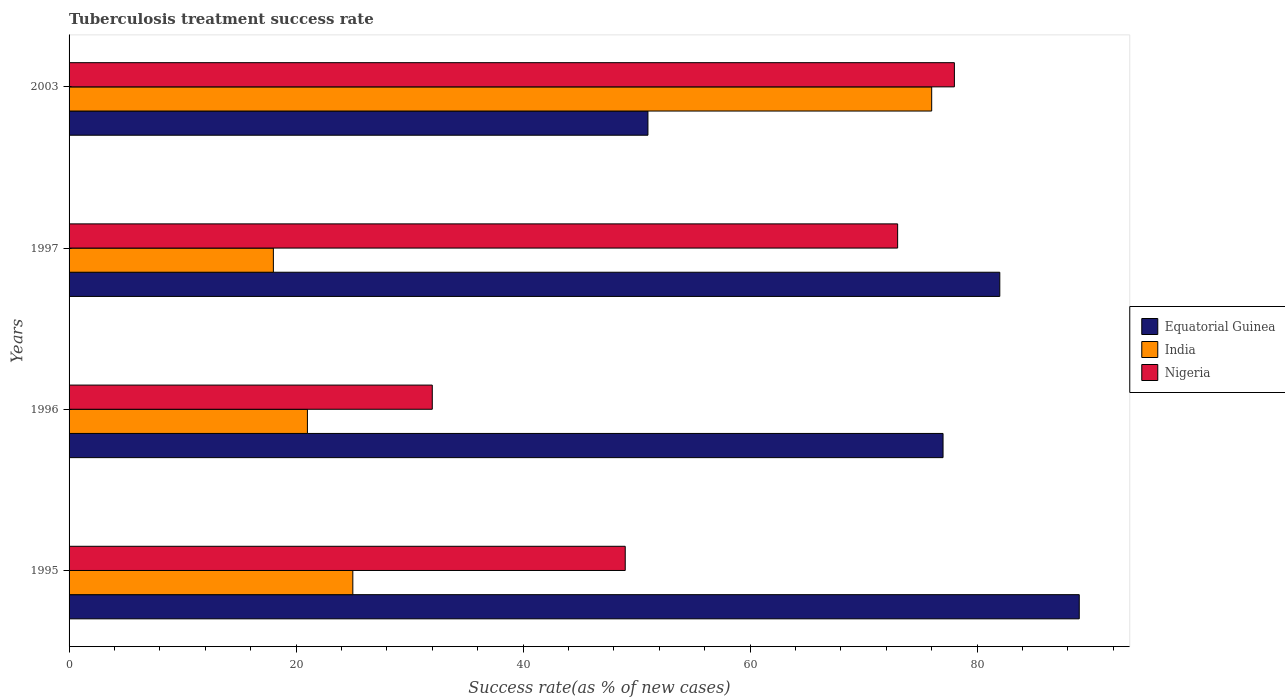How many different coloured bars are there?
Offer a very short reply. 3. What is the label of the 2nd group of bars from the top?
Offer a very short reply. 1997. In how many cases, is the number of bars for a given year not equal to the number of legend labels?
Provide a succinct answer. 0. What is the tuberculosis treatment success rate in Nigeria in 1995?
Keep it short and to the point. 49. Across all years, what is the maximum tuberculosis treatment success rate in India?
Provide a short and direct response. 76. Across all years, what is the minimum tuberculosis treatment success rate in Nigeria?
Keep it short and to the point. 32. In which year was the tuberculosis treatment success rate in Equatorial Guinea minimum?
Provide a short and direct response. 2003. What is the total tuberculosis treatment success rate in Equatorial Guinea in the graph?
Offer a very short reply. 299. What is the difference between the tuberculosis treatment success rate in Nigeria in 1996 and that in 2003?
Your answer should be very brief. -46. What is the difference between the tuberculosis treatment success rate in Nigeria in 1996 and the tuberculosis treatment success rate in India in 2003?
Your response must be concise. -44. What is the average tuberculosis treatment success rate in Nigeria per year?
Make the answer very short. 58. In how many years, is the tuberculosis treatment success rate in Nigeria greater than 48 %?
Keep it short and to the point. 3. What is the ratio of the tuberculosis treatment success rate in Nigeria in 1996 to that in 1997?
Provide a succinct answer. 0.44. Is the difference between the tuberculosis treatment success rate in Nigeria in 1995 and 2003 greater than the difference between the tuberculosis treatment success rate in Equatorial Guinea in 1995 and 2003?
Ensure brevity in your answer.  No. What is the difference between the highest and the lowest tuberculosis treatment success rate in India?
Keep it short and to the point. 58. Is the sum of the tuberculosis treatment success rate in India in 1995 and 1996 greater than the maximum tuberculosis treatment success rate in Nigeria across all years?
Offer a very short reply. No. What does the 1st bar from the top in 2003 represents?
Keep it short and to the point. Nigeria. What does the 3rd bar from the bottom in 1995 represents?
Make the answer very short. Nigeria. How many bars are there?
Keep it short and to the point. 12. How many years are there in the graph?
Your answer should be compact. 4. Where does the legend appear in the graph?
Provide a short and direct response. Center right. How many legend labels are there?
Your answer should be compact. 3. What is the title of the graph?
Provide a succinct answer. Tuberculosis treatment success rate. What is the label or title of the X-axis?
Your answer should be compact. Success rate(as % of new cases). What is the label or title of the Y-axis?
Offer a very short reply. Years. What is the Success rate(as % of new cases) of Equatorial Guinea in 1995?
Provide a short and direct response. 89. What is the Success rate(as % of new cases) in India in 1995?
Provide a succinct answer. 25. What is the Success rate(as % of new cases) of India in 1996?
Provide a short and direct response. 21. What is the Success rate(as % of new cases) in Nigeria in 1996?
Keep it short and to the point. 32. What is the Success rate(as % of new cases) of Equatorial Guinea in 1997?
Ensure brevity in your answer.  82. What is the Success rate(as % of new cases) of India in 1997?
Provide a succinct answer. 18. What is the Success rate(as % of new cases) of India in 2003?
Provide a short and direct response. 76. Across all years, what is the maximum Success rate(as % of new cases) in Equatorial Guinea?
Provide a short and direct response. 89. Across all years, what is the maximum Success rate(as % of new cases) of India?
Ensure brevity in your answer.  76. Across all years, what is the maximum Success rate(as % of new cases) in Nigeria?
Give a very brief answer. 78. Across all years, what is the minimum Success rate(as % of new cases) in Nigeria?
Your answer should be compact. 32. What is the total Success rate(as % of new cases) of Equatorial Guinea in the graph?
Offer a terse response. 299. What is the total Success rate(as % of new cases) of India in the graph?
Make the answer very short. 140. What is the total Success rate(as % of new cases) of Nigeria in the graph?
Give a very brief answer. 232. What is the difference between the Success rate(as % of new cases) in Equatorial Guinea in 1995 and that in 2003?
Give a very brief answer. 38. What is the difference between the Success rate(as % of new cases) in India in 1995 and that in 2003?
Your answer should be compact. -51. What is the difference between the Success rate(as % of new cases) of Nigeria in 1995 and that in 2003?
Your answer should be compact. -29. What is the difference between the Success rate(as % of new cases) in Equatorial Guinea in 1996 and that in 1997?
Ensure brevity in your answer.  -5. What is the difference between the Success rate(as % of new cases) of Nigeria in 1996 and that in 1997?
Ensure brevity in your answer.  -41. What is the difference between the Success rate(as % of new cases) in Equatorial Guinea in 1996 and that in 2003?
Provide a short and direct response. 26. What is the difference between the Success rate(as % of new cases) of India in 1996 and that in 2003?
Provide a short and direct response. -55. What is the difference between the Success rate(as % of new cases) of Nigeria in 1996 and that in 2003?
Ensure brevity in your answer.  -46. What is the difference between the Success rate(as % of new cases) in Equatorial Guinea in 1997 and that in 2003?
Provide a succinct answer. 31. What is the difference between the Success rate(as % of new cases) in India in 1997 and that in 2003?
Give a very brief answer. -58. What is the difference between the Success rate(as % of new cases) of Nigeria in 1997 and that in 2003?
Provide a short and direct response. -5. What is the difference between the Success rate(as % of new cases) in Equatorial Guinea in 1995 and the Success rate(as % of new cases) in Nigeria in 1996?
Provide a short and direct response. 57. What is the difference between the Success rate(as % of new cases) in India in 1995 and the Success rate(as % of new cases) in Nigeria in 1996?
Make the answer very short. -7. What is the difference between the Success rate(as % of new cases) in Equatorial Guinea in 1995 and the Success rate(as % of new cases) in India in 1997?
Provide a succinct answer. 71. What is the difference between the Success rate(as % of new cases) of India in 1995 and the Success rate(as % of new cases) of Nigeria in 1997?
Provide a succinct answer. -48. What is the difference between the Success rate(as % of new cases) of India in 1995 and the Success rate(as % of new cases) of Nigeria in 2003?
Provide a succinct answer. -53. What is the difference between the Success rate(as % of new cases) of Equatorial Guinea in 1996 and the Success rate(as % of new cases) of India in 1997?
Keep it short and to the point. 59. What is the difference between the Success rate(as % of new cases) of India in 1996 and the Success rate(as % of new cases) of Nigeria in 1997?
Your answer should be compact. -52. What is the difference between the Success rate(as % of new cases) of Equatorial Guinea in 1996 and the Success rate(as % of new cases) of Nigeria in 2003?
Provide a succinct answer. -1. What is the difference between the Success rate(as % of new cases) of India in 1996 and the Success rate(as % of new cases) of Nigeria in 2003?
Offer a terse response. -57. What is the difference between the Success rate(as % of new cases) in Equatorial Guinea in 1997 and the Success rate(as % of new cases) in Nigeria in 2003?
Offer a very short reply. 4. What is the difference between the Success rate(as % of new cases) of India in 1997 and the Success rate(as % of new cases) of Nigeria in 2003?
Your response must be concise. -60. What is the average Success rate(as % of new cases) in Equatorial Guinea per year?
Provide a succinct answer. 74.75. What is the average Success rate(as % of new cases) in Nigeria per year?
Make the answer very short. 58. In the year 1995, what is the difference between the Success rate(as % of new cases) of Equatorial Guinea and Success rate(as % of new cases) of Nigeria?
Your response must be concise. 40. In the year 1996, what is the difference between the Success rate(as % of new cases) in Equatorial Guinea and Success rate(as % of new cases) in Nigeria?
Offer a terse response. 45. In the year 1997, what is the difference between the Success rate(as % of new cases) in Equatorial Guinea and Success rate(as % of new cases) in India?
Keep it short and to the point. 64. In the year 1997, what is the difference between the Success rate(as % of new cases) in Equatorial Guinea and Success rate(as % of new cases) in Nigeria?
Your answer should be compact. 9. In the year 1997, what is the difference between the Success rate(as % of new cases) of India and Success rate(as % of new cases) of Nigeria?
Ensure brevity in your answer.  -55. In the year 2003, what is the difference between the Success rate(as % of new cases) of Equatorial Guinea and Success rate(as % of new cases) of Nigeria?
Your response must be concise. -27. In the year 2003, what is the difference between the Success rate(as % of new cases) in India and Success rate(as % of new cases) in Nigeria?
Ensure brevity in your answer.  -2. What is the ratio of the Success rate(as % of new cases) of Equatorial Guinea in 1995 to that in 1996?
Your answer should be compact. 1.16. What is the ratio of the Success rate(as % of new cases) of India in 1995 to that in 1996?
Offer a terse response. 1.19. What is the ratio of the Success rate(as % of new cases) in Nigeria in 1995 to that in 1996?
Your answer should be compact. 1.53. What is the ratio of the Success rate(as % of new cases) in Equatorial Guinea in 1995 to that in 1997?
Make the answer very short. 1.09. What is the ratio of the Success rate(as % of new cases) of India in 1995 to that in 1997?
Your answer should be very brief. 1.39. What is the ratio of the Success rate(as % of new cases) in Nigeria in 1995 to that in 1997?
Make the answer very short. 0.67. What is the ratio of the Success rate(as % of new cases) of Equatorial Guinea in 1995 to that in 2003?
Offer a terse response. 1.75. What is the ratio of the Success rate(as % of new cases) of India in 1995 to that in 2003?
Give a very brief answer. 0.33. What is the ratio of the Success rate(as % of new cases) of Nigeria in 1995 to that in 2003?
Your answer should be compact. 0.63. What is the ratio of the Success rate(as % of new cases) in Equatorial Guinea in 1996 to that in 1997?
Your answer should be very brief. 0.94. What is the ratio of the Success rate(as % of new cases) in India in 1996 to that in 1997?
Ensure brevity in your answer.  1.17. What is the ratio of the Success rate(as % of new cases) of Nigeria in 1996 to that in 1997?
Your answer should be very brief. 0.44. What is the ratio of the Success rate(as % of new cases) in Equatorial Guinea in 1996 to that in 2003?
Provide a short and direct response. 1.51. What is the ratio of the Success rate(as % of new cases) in India in 1996 to that in 2003?
Provide a succinct answer. 0.28. What is the ratio of the Success rate(as % of new cases) of Nigeria in 1996 to that in 2003?
Give a very brief answer. 0.41. What is the ratio of the Success rate(as % of new cases) in Equatorial Guinea in 1997 to that in 2003?
Offer a terse response. 1.61. What is the ratio of the Success rate(as % of new cases) of India in 1997 to that in 2003?
Provide a succinct answer. 0.24. What is the ratio of the Success rate(as % of new cases) in Nigeria in 1997 to that in 2003?
Ensure brevity in your answer.  0.94. What is the difference between the highest and the second highest Success rate(as % of new cases) of India?
Provide a short and direct response. 51. What is the difference between the highest and the lowest Success rate(as % of new cases) in Nigeria?
Make the answer very short. 46. 